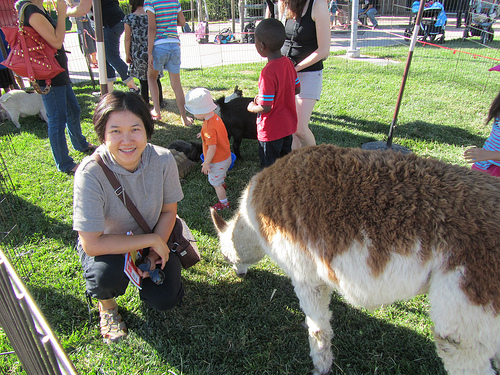Please provide a short description for this region: [0.01, 0.16, 0.12, 0.31]. The region features a large red purse, making it a noticeable accessory within the image. 